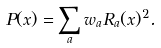Convert formula to latex. <formula><loc_0><loc_0><loc_500><loc_500>P ( x ) = \sum _ { a } w _ { a } R _ { a } ( x ) ^ { 2 } .</formula> 